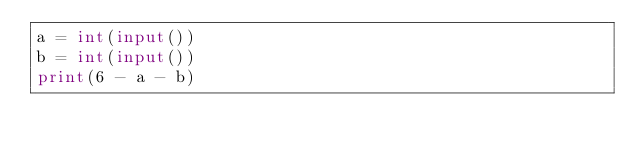Convert code to text. <code><loc_0><loc_0><loc_500><loc_500><_Python_>a = int(input())
b = int(input())
print(6 - a - b)</code> 